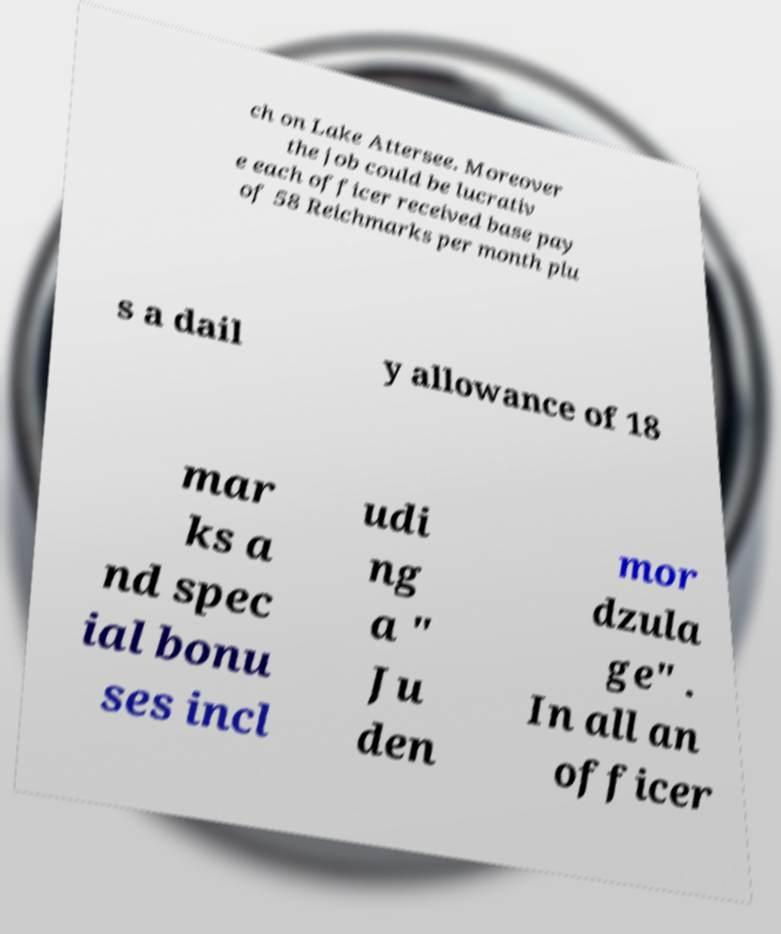I need the written content from this picture converted into text. Can you do that? ch on Lake Attersee. Moreover the job could be lucrativ e each officer received base pay of 58 Reichmarks per month plu s a dail y allowance of 18 mar ks a nd spec ial bonu ses incl udi ng a " Ju den mor dzula ge" . In all an officer 